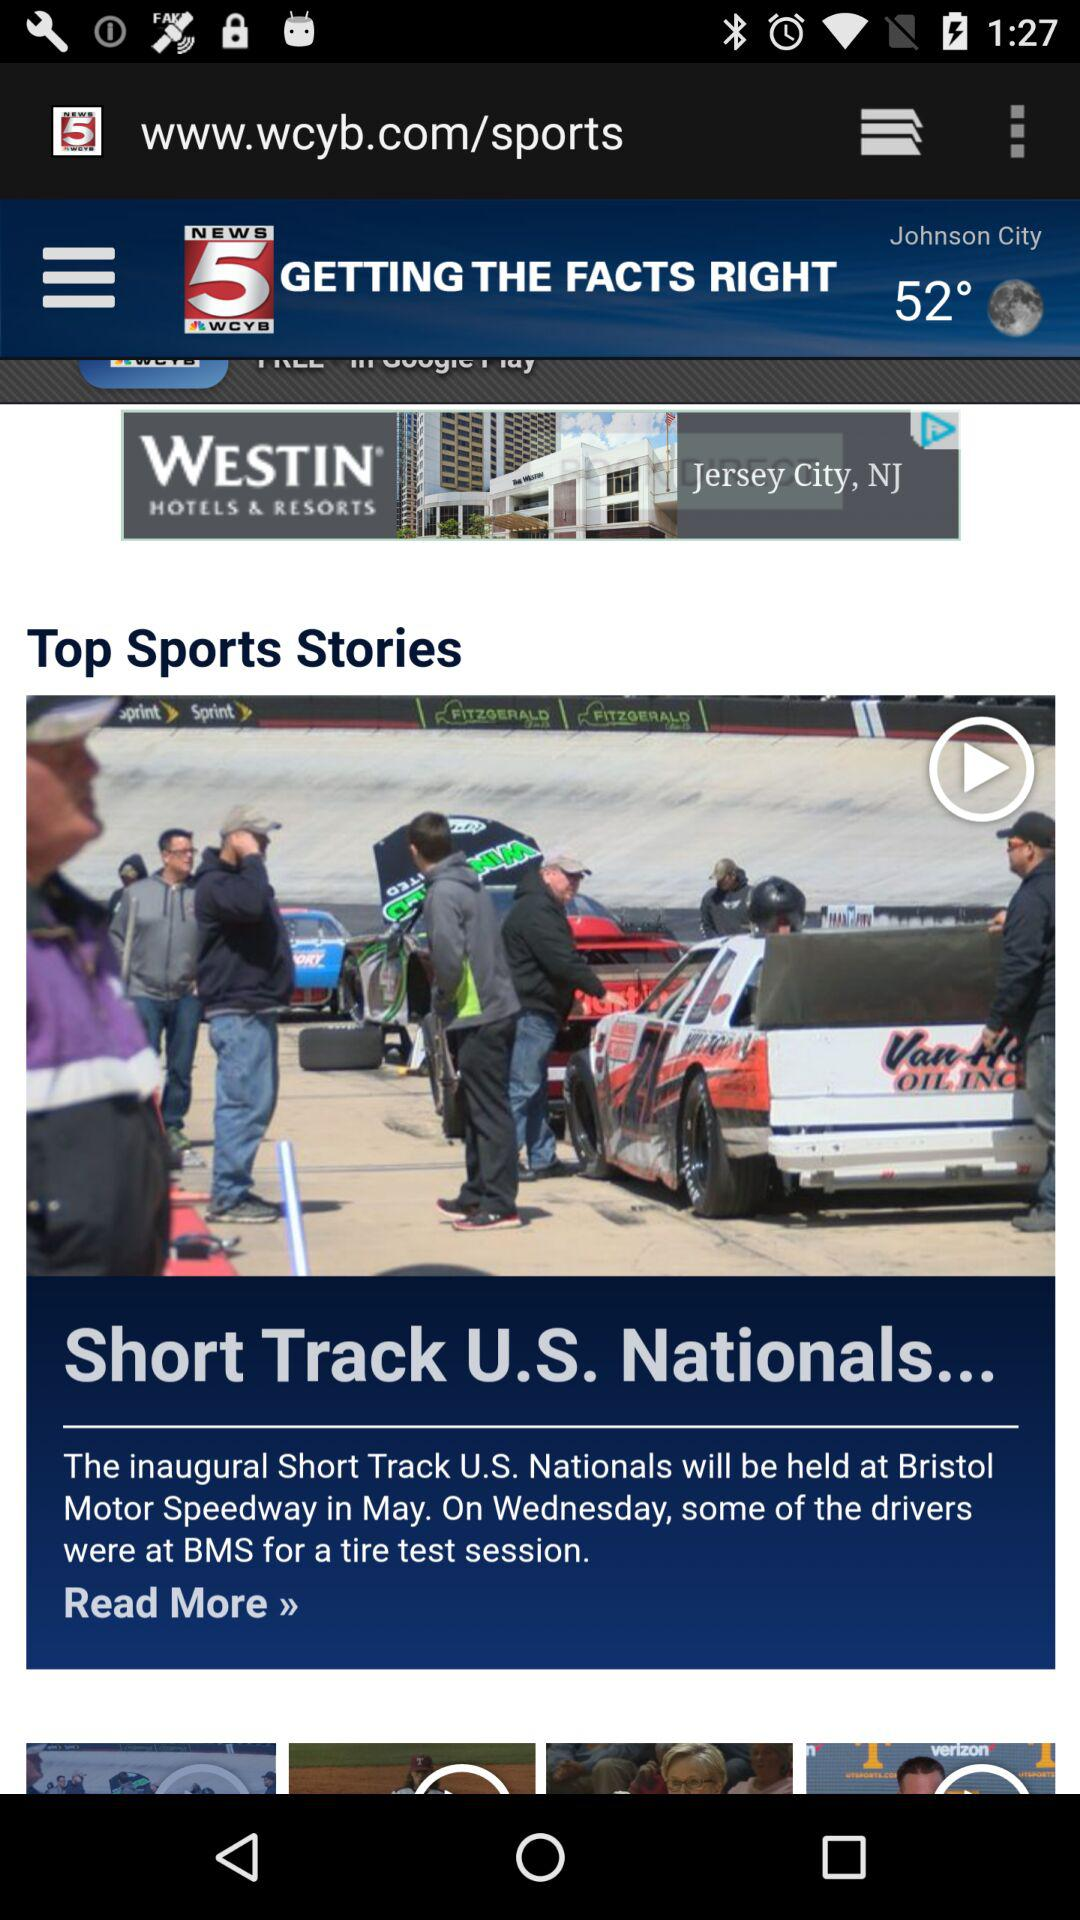What is the month of the inaugural short track? The month of the inaugural short track is May. 